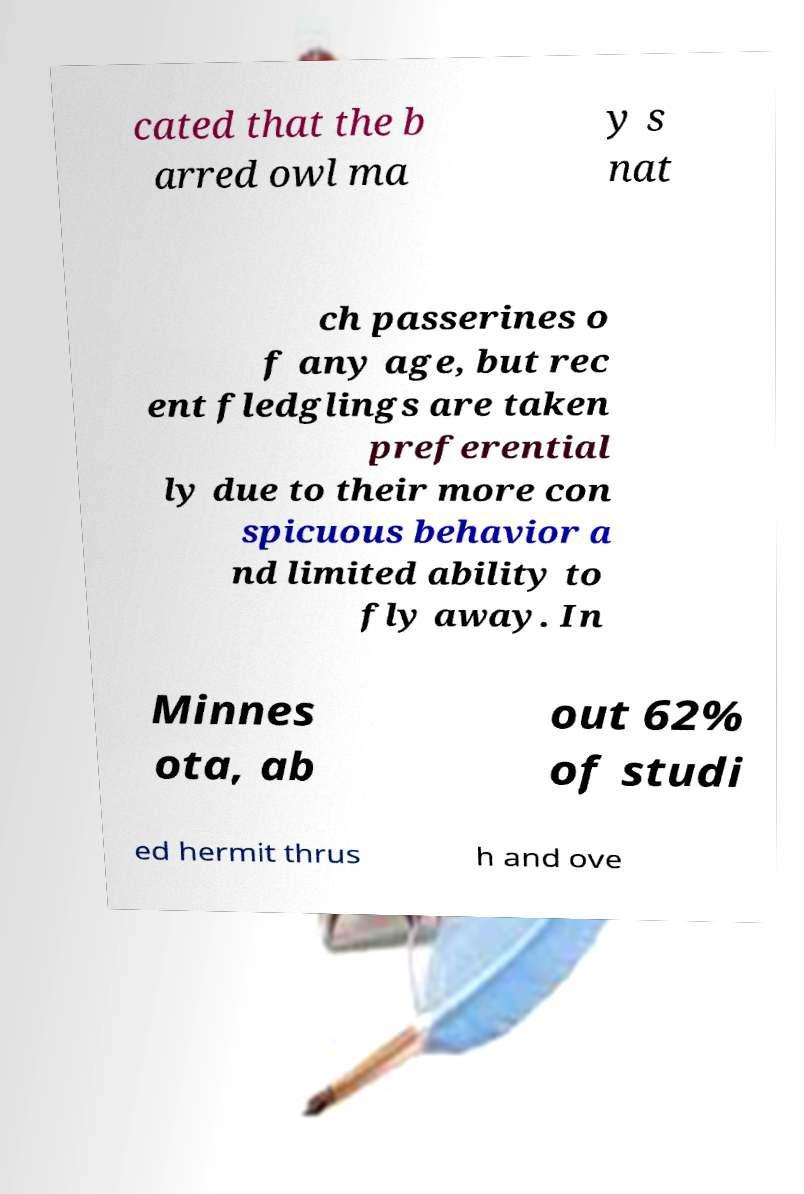Please read and relay the text visible in this image. What does it say? cated that the b arred owl ma y s nat ch passerines o f any age, but rec ent fledglings are taken preferential ly due to their more con spicuous behavior a nd limited ability to fly away. In Minnes ota, ab out 62% of studi ed hermit thrus h and ove 